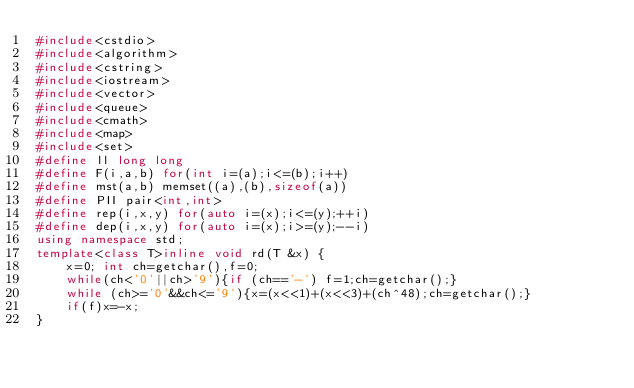<code> <loc_0><loc_0><loc_500><loc_500><_C++_>#include<cstdio>
#include<algorithm>
#include<cstring>
#include<iostream>
#include<vector>
#include<queue>
#include<cmath>
#include<map>
#include<set>
#define ll long long
#define F(i,a,b) for(int i=(a);i<=(b);i++)
#define mst(a,b) memset((a),(b),sizeof(a))
#define PII pair<int,int>
#define rep(i,x,y) for(auto i=(x);i<=(y);++i)
#define dep(i,x,y) for(auto i=(x);i>=(y);--i)
using namespace std;
template<class T>inline void rd(T &x) {
    x=0; int ch=getchar(),f=0;
    while(ch<'0'||ch>'9'){if (ch=='-') f=1;ch=getchar();}
    while (ch>='0'&&ch<='9'){x=(x<<1)+(x<<3)+(ch^48);ch=getchar();}
    if(f)x=-x;
}</code> 